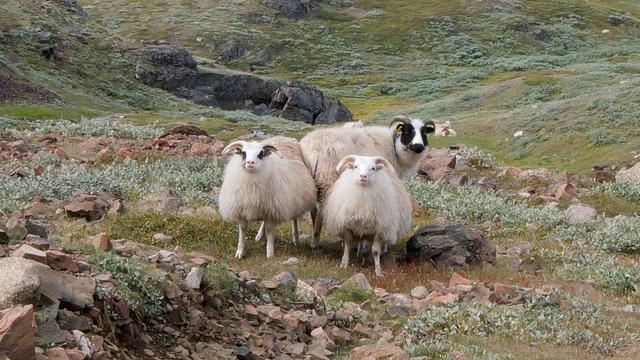What are these animals called? sheep 